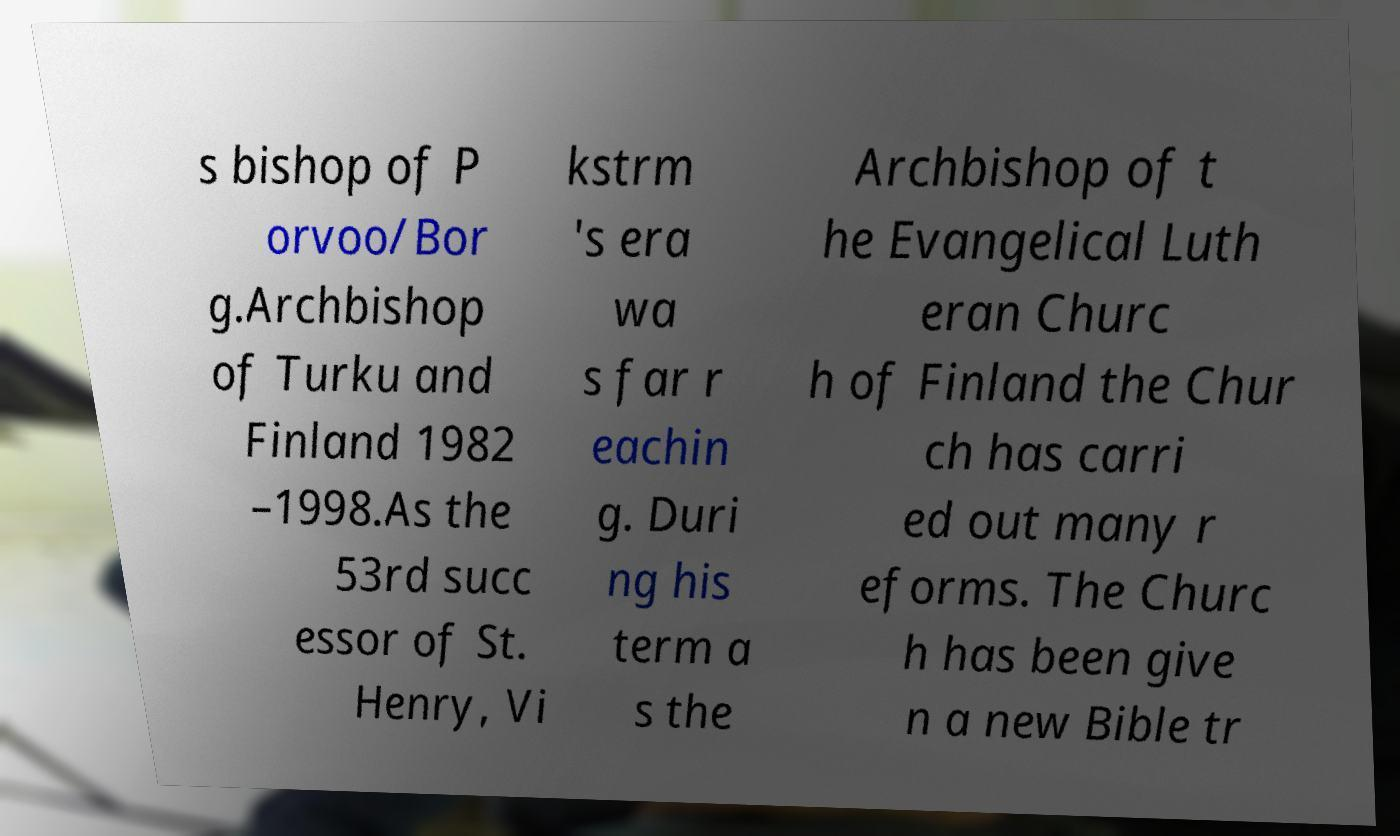For documentation purposes, I need the text within this image transcribed. Could you provide that? s bishop of P orvoo/Bor g.Archbishop of Turku and Finland 1982 –1998.As the 53rd succ essor of St. Henry, Vi kstrm 's era wa s far r eachin g. Duri ng his term a s the Archbishop of t he Evangelical Luth eran Churc h of Finland the Chur ch has carri ed out many r eforms. The Churc h has been give n a new Bible tr 